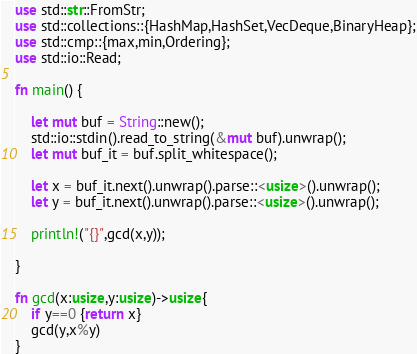Convert code to text. <code><loc_0><loc_0><loc_500><loc_500><_Rust_>use std::str::FromStr;
use std::collections::{HashMap,HashSet,VecDeque,BinaryHeap};
use std::cmp::{max,min,Ordering};
use std::io::Read;

fn main() {

    let mut buf = String::new();
    std::io::stdin().read_to_string(&mut buf).unwrap();
    let mut buf_it = buf.split_whitespace();

    let x = buf_it.next().unwrap().parse::<usize>().unwrap();
    let y = buf_it.next().unwrap().parse::<usize>().unwrap();

    println!("{}",gcd(x,y));

}

fn gcd(x:usize,y:usize)->usize{
    if y==0 {return x}
    gcd(y,x%y)
}
</code> 